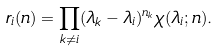Convert formula to latex. <formula><loc_0><loc_0><loc_500><loc_500>r _ { i } ( n ) = \prod _ { k \ne i } ( \lambda _ { k } - \lambda _ { i } ) ^ { n _ { k } } \chi ( \lambda _ { i } ; n ) .</formula> 